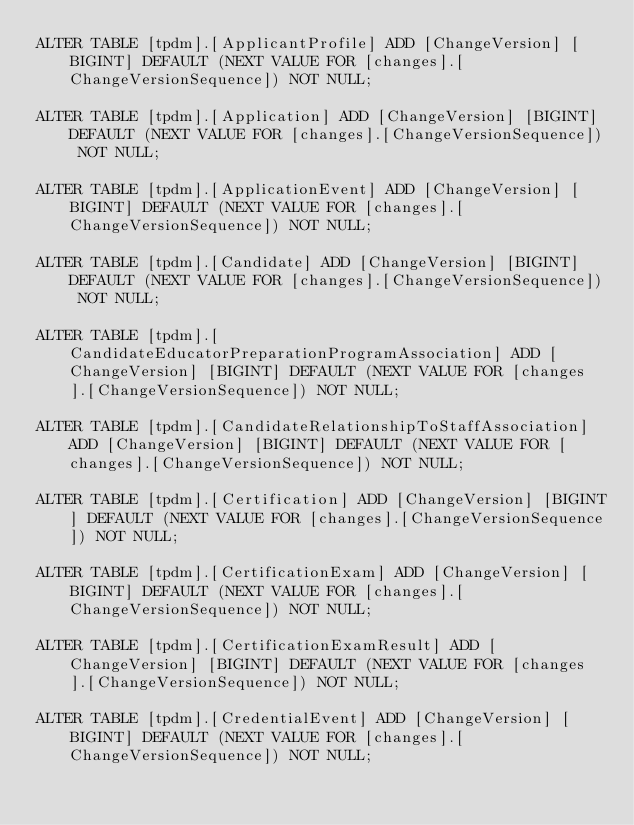<code> <loc_0><loc_0><loc_500><loc_500><_SQL_>ALTER TABLE [tpdm].[ApplicantProfile] ADD [ChangeVersion] [BIGINT] DEFAULT (NEXT VALUE FOR [changes].[ChangeVersionSequence]) NOT NULL;

ALTER TABLE [tpdm].[Application] ADD [ChangeVersion] [BIGINT] DEFAULT (NEXT VALUE FOR [changes].[ChangeVersionSequence]) NOT NULL;

ALTER TABLE [tpdm].[ApplicationEvent] ADD [ChangeVersion] [BIGINT] DEFAULT (NEXT VALUE FOR [changes].[ChangeVersionSequence]) NOT NULL;

ALTER TABLE [tpdm].[Candidate] ADD [ChangeVersion] [BIGINT] DEFAULT (NEXT VALUE FOR [changes].[ChangeVersionSequence]) NOT NULL;

ALTER TABLE [tpdm].[CandidateEducatorPreparationProgramAssociation] ADD [ChangeVersion] [BIGINT] DEFAULT (NEXT VALUE FOR [changes].[ChangeVersionSequence]) NOT NULL;

ALTER TABLE [tpdm].[CandidateRelationshipToStaffAssociation] ADD [ChangeVersion] [BIGINT] DEFAULT (NEXT VALUE FOR [changes].[ChangeVersionSequence]) NOT NULL;

ALTER TABLE [tpdm].[Certification] ADD [ChangeVersion] [BIGINT] DEFAULT (NEXT VALUE FOR [changes].[ChangeVersionSequence]) NOT NULL;

ALTER TABLE [tpdm].[CertificationExam] ADD [ChangeVersion] [BIGINT] DEFAULT (NEXT VALUE FOR [changes].[ChangeVersionSequence]) NOT NULL;

ALTER TABLE [tpdm].[CertificationExamResult] ADD [ChangeVersion] [BIGINT] DEFAULT (NEXT VALUE FOR [changes].[ChangeVersionSequence]) NOT NULL;

ALTER TABLE [tpdm].[CredentialEvent] ADD [ChangeVersion] [BIGINT] DEFAULT (NEXT VALUE FOR [changes].[ChangeVersionSequence]) NOT NULL;
</code> 